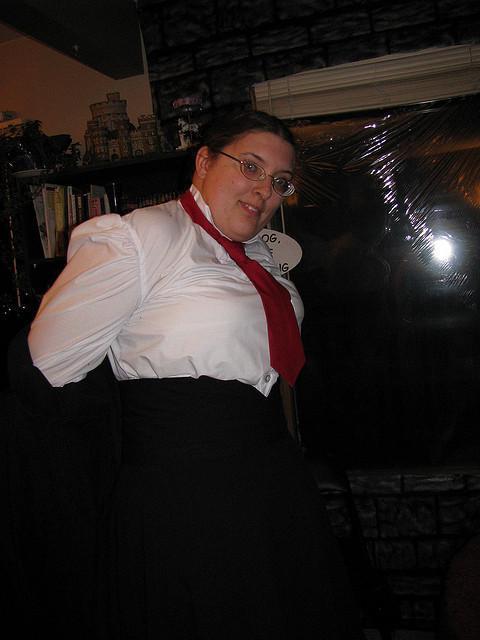How many books are in the picture?
Give a very brief answer. 1. 